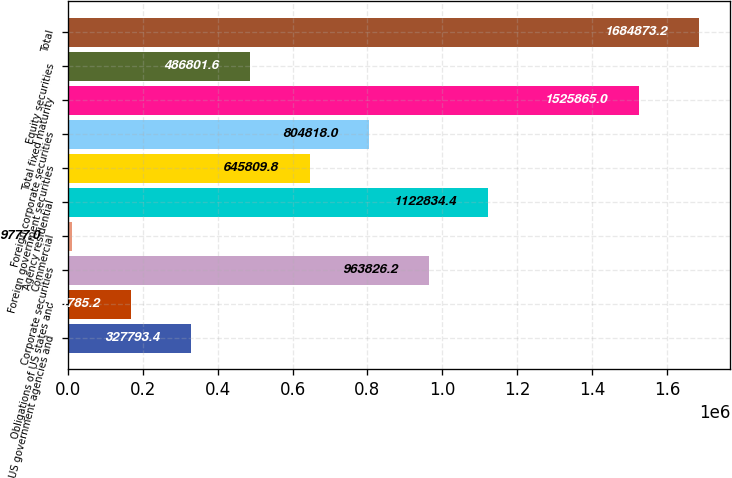Convert chart to OTSL. <chart><loc_0><loc_0><loc_500><loc_500><bar_chart><fcel>US government agencies and<fcel>Obligations of US states and<fcel>Corporate securities<fcel>Commercial<fcel>Agency residential<fcel>Foreign government securities<fcel>Foreign corporate securities<fcel>Total fixed maturity<fcel>Equity securities<fcel>Total<nl><fcel>327793<fcel>168785<fcel>963826<fcel>9777<fcel>1.12283e+06<fcel>645810<fcel>804818<fcel>1.52586e+06<fcel>486802<fcel>1.68487e+06<nl></chart> 